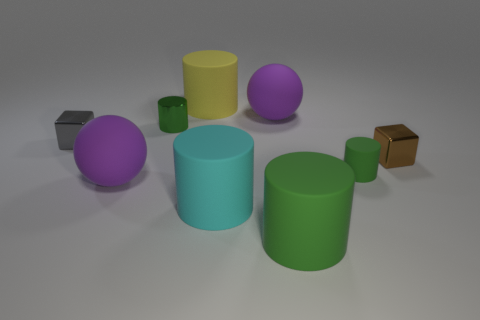Subtract all gray balls. How many green cylinders are left? 3 Subtract 1 cylinders. How many cylinders are left? 4 Subtract all cyan cylinders. How many cylinders are left? 4 Subtract all tiny metal cylinders. How many cylinders are left? 4 Subtract all purple cylinders. Subtract all yellow blocks. How many cylinders are left? 5 Add 1 tiny green matte cylinders. How many objects exist? 10 Subtract all cylinders. How many objects are left? 4 Add 4 tiny cubes. How many tiny cubes exist? 6 Subtract 0 green spheres. How many objects are left? 9 Subtract all purple things. Subtract all purple things. How many objects are left? 5 